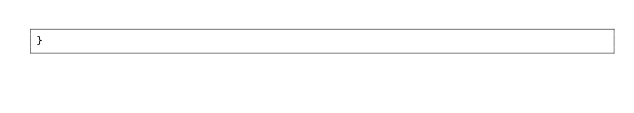<code> <loc_0><loc_0><loc_500><loc_500><_JavaScript_>}
</code> 